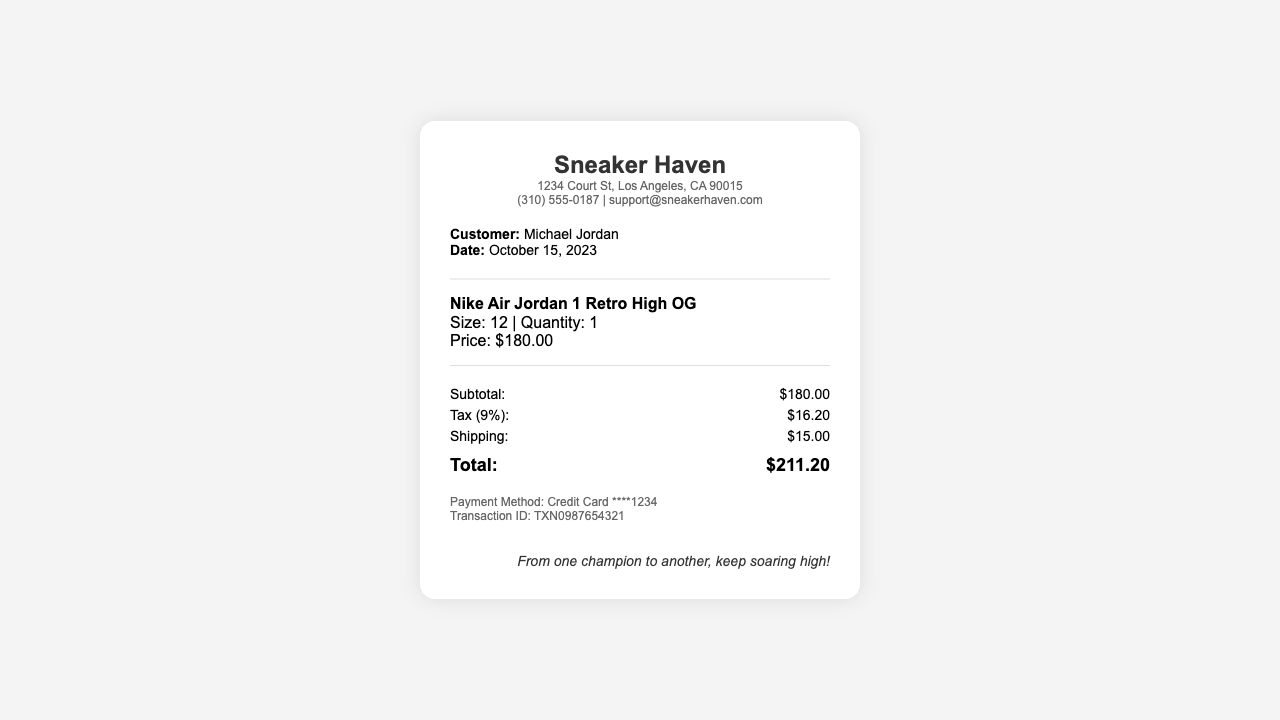What is the name of the store? The store name is prominently displayed at the top of the receipt.
Answer: Sneaker Haven What is the customer's name? The customer's name is mentioned in the customer info section.
Answer: Michael Jordan What is the total amount paid? The total is calculated by adding the subtotal, tax, and shipping fees.
Answer: $211.20 What is the size of the sneakers purchased? The size is listed in the item details section for the specific sneakers.
Answer: 12 How much is the tax charged? The tax amount is explicitly mentioned under the summary section.
Answer: $16.20 What payment method was used? The payment method is noted in the payment info section of the receipt.
Answer: Credit Card What is the shipping fee? The shipping fee is noted under the summary section along with other charges.
Answer: $15.00 What date was the purchase made? The date of the transaction is listed in the customer info section.
Answer: October 15, 2023 How many pairs of sneakers were purchased? The quantity of sneakers is noted in the item details for the sneakers purchased.
Answer: 1 